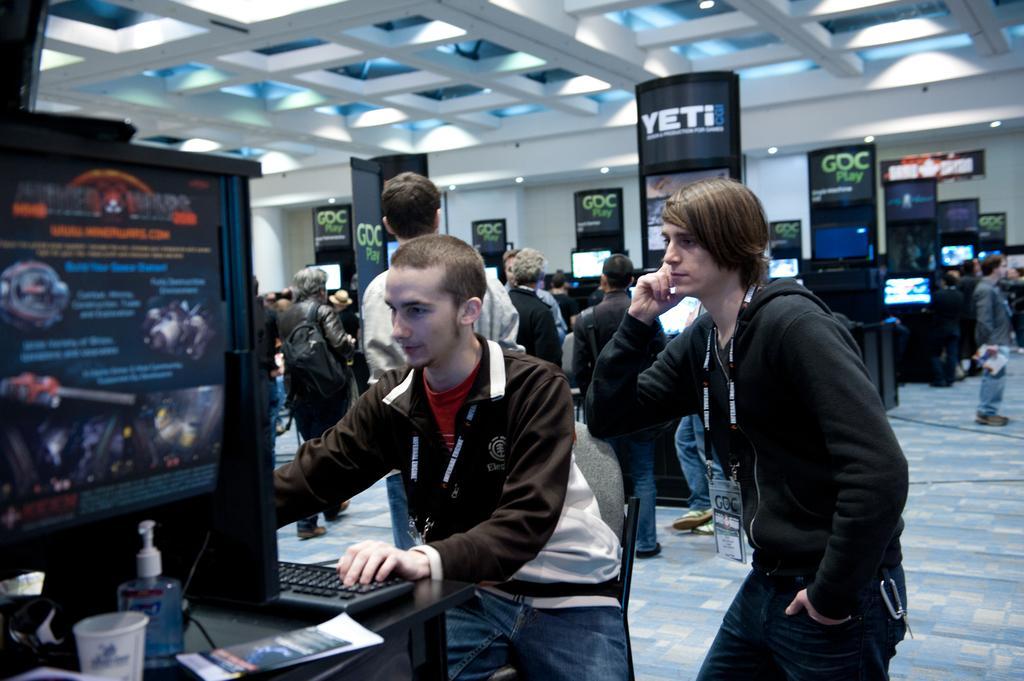Can you describe this image briefly? In this image we can see there are a few people standing and few people walking on the ground and holding an object. And there is the person sitting on the chair and working with a keyboard. And we can see the table, on the table there are papers, cup, bottle and a few objects. And at the back we can see the boards with screen. And at the top we can see the ceiling and lights. 